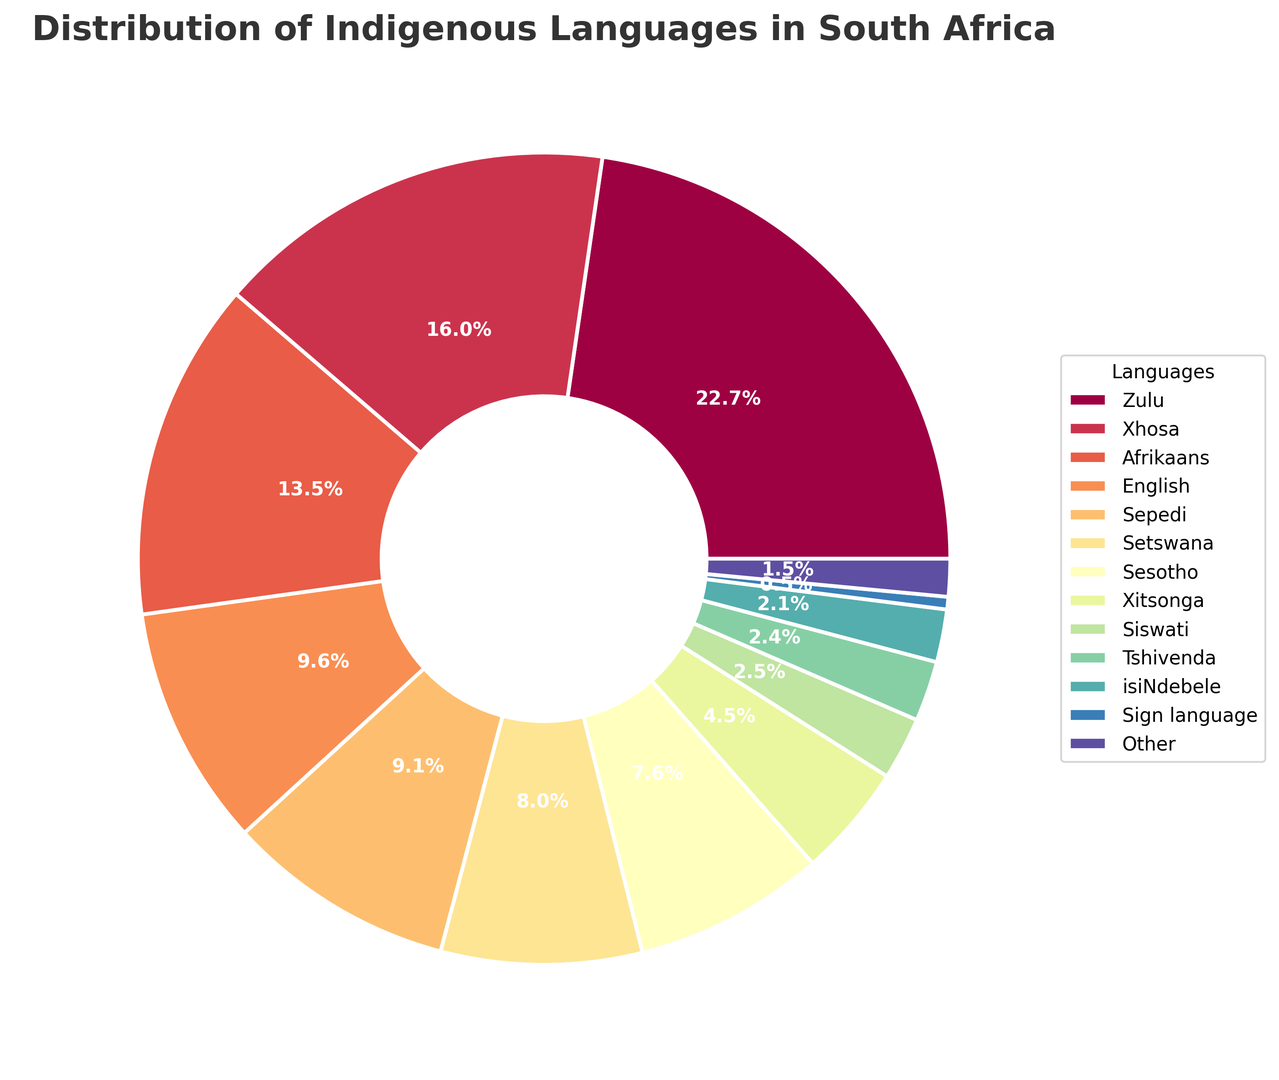Which language has the highest percentage of speakers? Locate the sector with the largest area and the corresponding label, which is Zulu at 22.7%.
Answer: Zulu What is the combined percentage of Xhosa and Afrikaans speakers? Find the percentages for Xhosa and Afrikaans from the chart (16.0% and 13.5%) and add them together (16.0 + 13.5).
Answer: 29.5% Which three languages have the smallest percentages of speakers, and what are their combined percentages? Identify the sectors with the smallest areas labeled Siswati (2.5%), Tshivenda (2.4%), and isiNdebele (2.1%). Add these percentages (2.5 + 2.4 + 2.1).
Answer: Siswati, Tshivenda, isiNdebele, 7.0% Compare the percentage of Setswana speakers to that of Sepedi speakers. Which group is larger and by how much? Find the sectors with labels Setswana (8.0%) and Sepedi (9.1%) and calculate the difference (9.1 - 8.0). Since Sepedi has a higher percentage, it is larger.
Answer: Sepedi by 1.1% What is the percentage difference between the most and least spoken indigenous languages? Find the sectors for the most spoken (Zulu at 22.7%) and the least spoken (Sign language at 0.5%) languages. Subtract the smaller percentage from the larger one (22.7 - 0.5).
Answer: 22.2% What percentage of the population speaks either English or Sign language? Identify and sum the sectors for English (9.6%) and Sign language (0.5%).
Answer: 10.1% Which language group is represented by approximately 4.5% of the population, and how does that compare to Siswati in terms of percentage? Locate the sector labeled Xitsonga (4.5%) and compare this to Siswati (2.5%). Subtract the smaller percentage from the larger one (4.5 - 2.5).
Answer: Xitsonga, 2.0% What is the total percentage for the Sotho languages (Sesotho, Setswana, and Sepedi combined)? Identify the sectors labeled Sesotho (7.6%), Setswana (8.0%), and Sepedi (9.1%), and sum their percentages (7.6 + 8.0 + 9.1).
Answer: 24.7% What percentage of people speak languages other than the eleven official indigenous languages listed (including Sign language)? Identify the sector labeled Other (1.5%). This represents languages not listed among the eleven plus Sign language.
Answer: 1.5% How does the percentage of Afrikaans speakers compare to the average percentage of all other languages listed? Calculate the average percentage of all languages excluding Afrikaans. Sum the percentages of all other languages (subtract Afrikaans's 13.5% from 100%) and divide by the number of other languages (11). Compare this to Afrikaans's 13.5%.
Answer: Afrikaans, 13.5%; Other languages average, 7.86% 